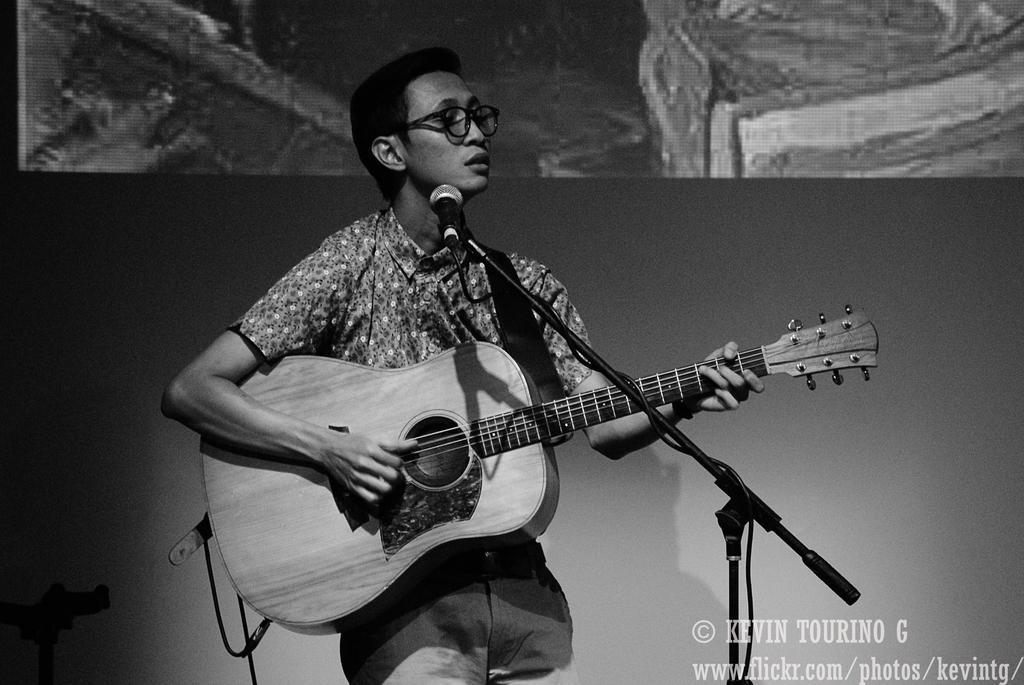Could you give a brief overview of what you see in this image? In the image we can say that, this person is standing and having a guitar in his hands. This is a microphone, spectacle and this is a water mark. 